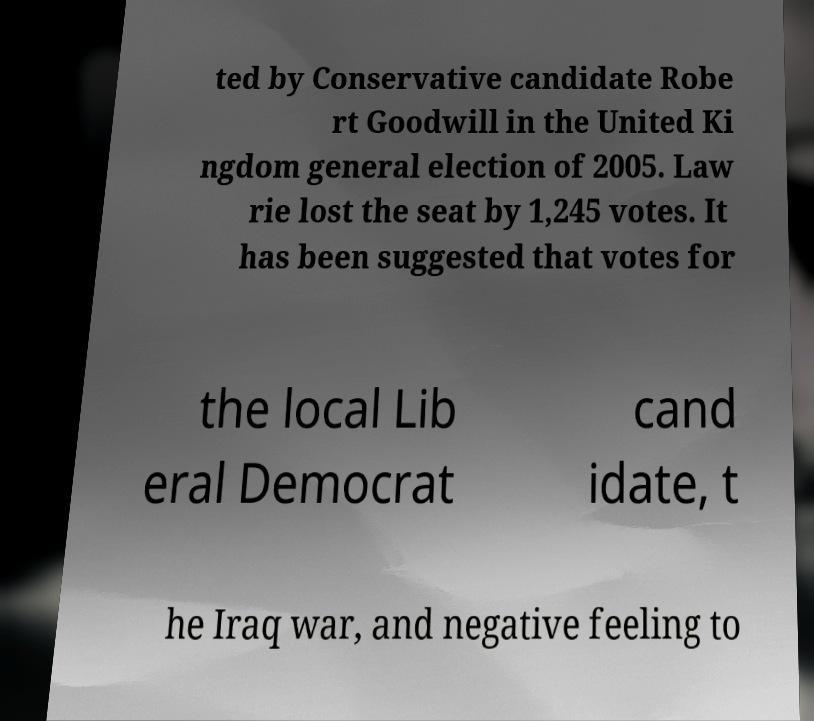What messages or text are displayed in this image? I need them in a readable, typed format. ted by Conservative candidate Robe rt Goodwill in the United Ki ngdom general election of 2005. Law rie lost the seat by 1,245 votes. It has been suggested that votes for the local Lib eral Democrat cand idate, t he Iraq war, and negative feeling to 